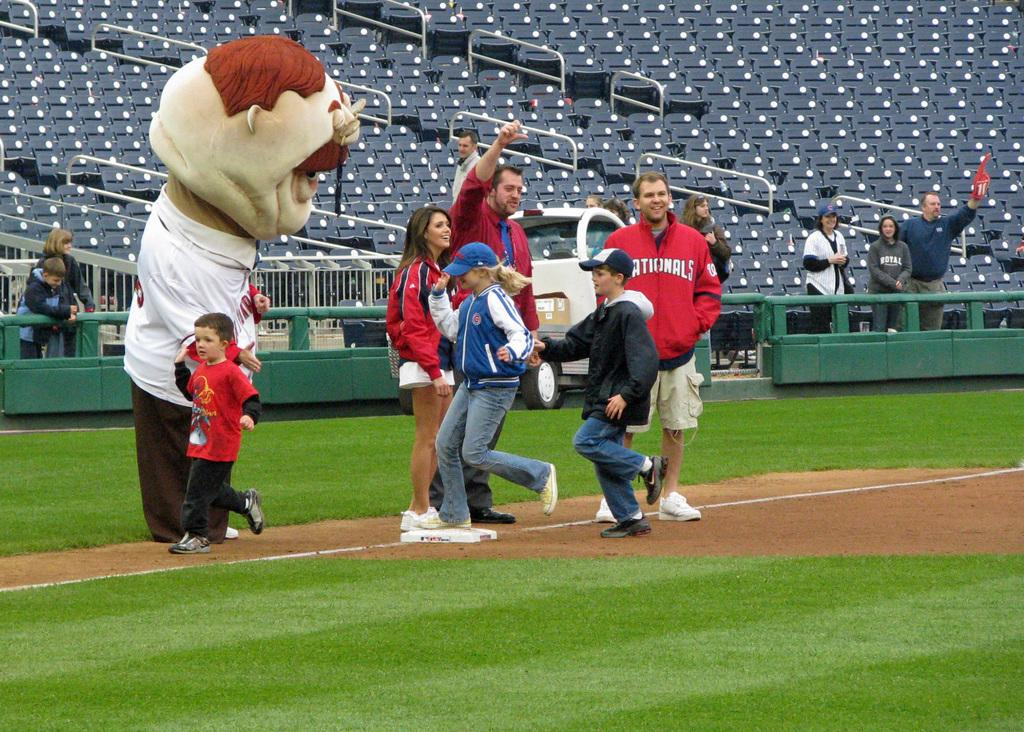<image>
Summarize the visual content of the image. people are standing with a mascot on a baseball field and one is wearing a Nationals jacket 